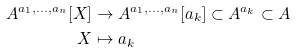Convert formula to latex. <formula><loc_0><loc_0><loc_500><loc_500>A ^ { a _ { 1 } , \dots , a _ { n } } [ X ] & \rightarrow A ^ { a _ { 1 } , \dots , a _ { n } } [ a _ { k } ] \subset A ^ { a _ { k } } \subset A \\ X & \mapsto a _ { k }</formula> 